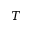Convert formula to latex. <formula><loc_0><loc_0><loc_500><loc_500>T</formula> 